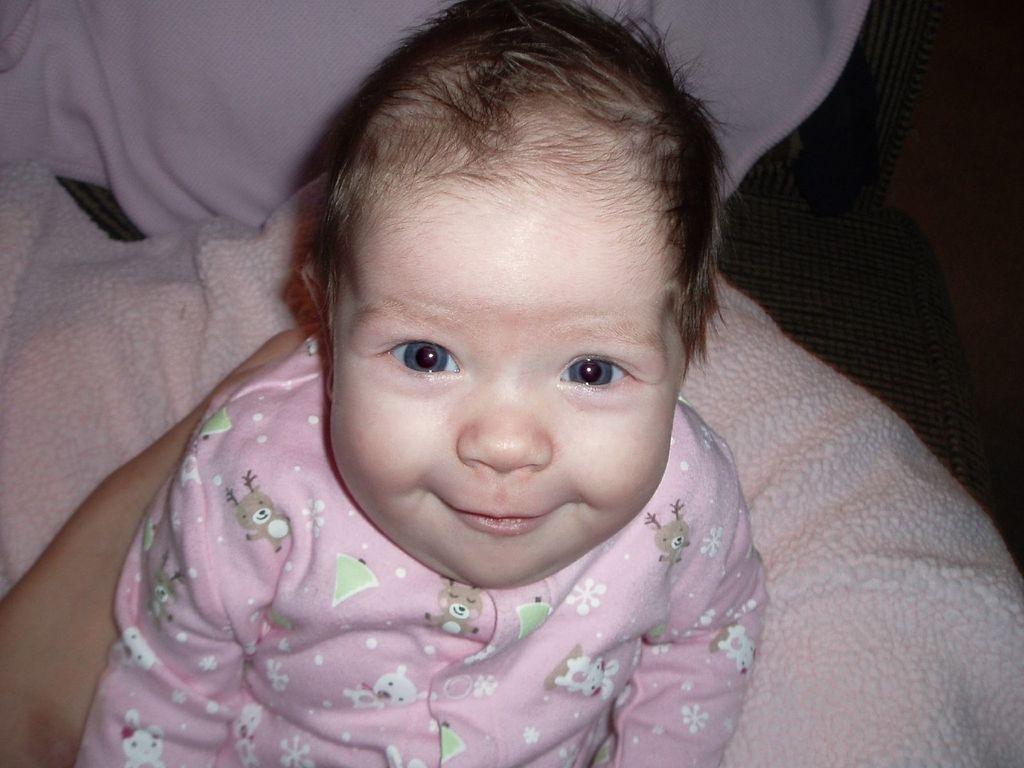How would you summarize this image in a sentence or two? In the center of the image we can see a kid smiling. At the bottom there is a cloth. On the left we can see a person's hand. 